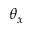<formula> <loc_0><loc_0><loc_500><loc_500>\theta _ { x }</formula> 